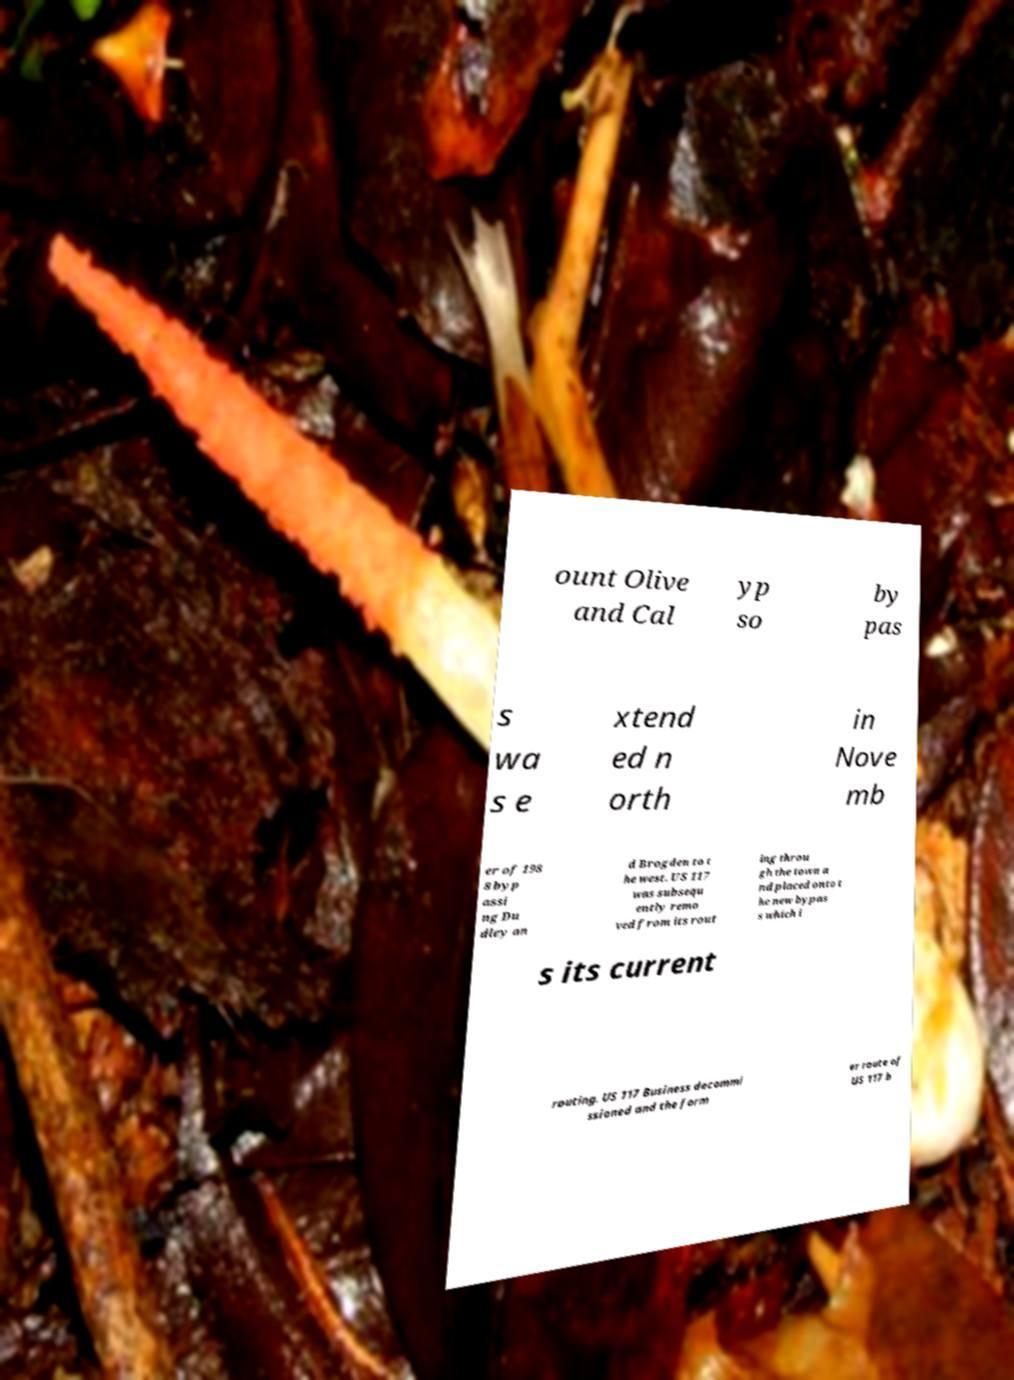I need the written content from this picture converted into text. Can you do that? ount Olive and Cal yp so by pas s wa s e xtend ed n orth in Nove mb er of 198 8 byp assi ng Du dley an d Brogden to t he west. US 117 was subsequ ently remo ved from its rout ing throu gh the town a nd placed onto t he new bypas s which i s its current routing. US 117 Business decommi ssioned and the form er route of US 117 b 